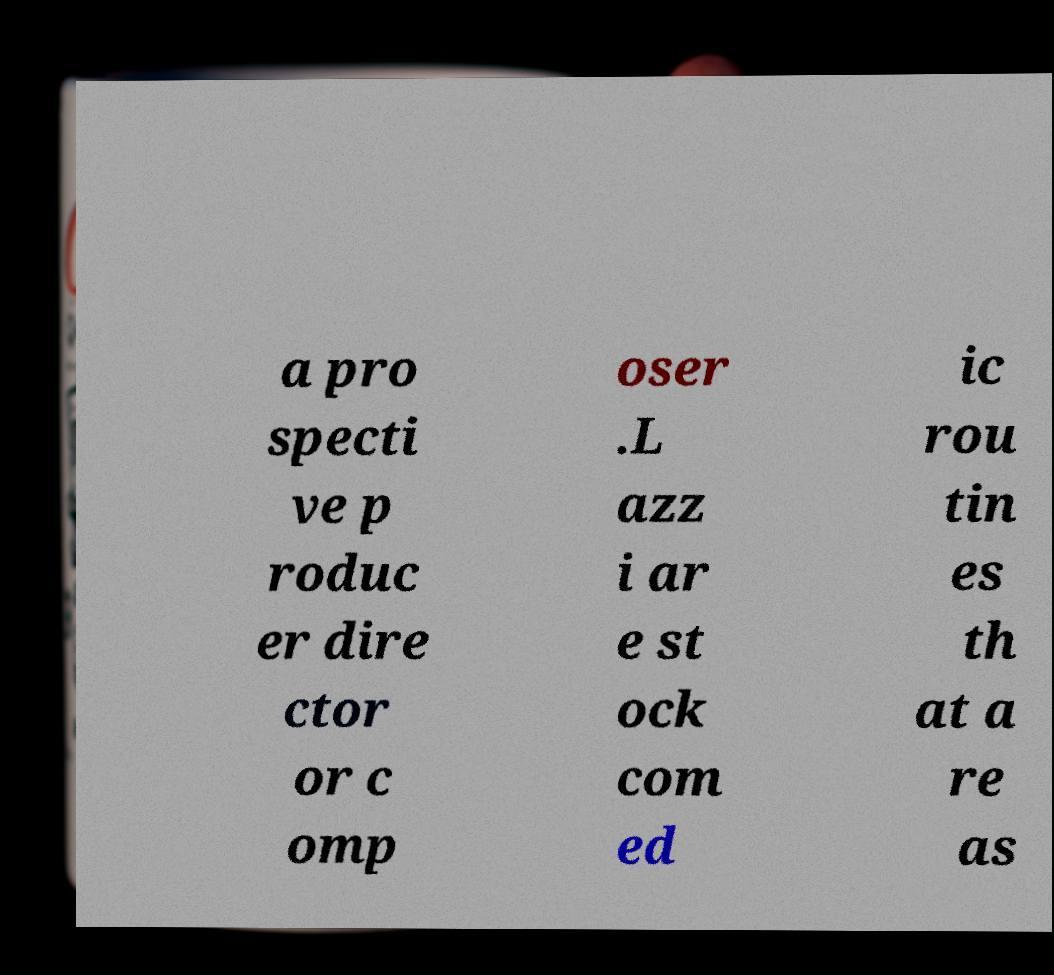What messages or text are displayed in this image? I need them in a readable, typed format. a pro specti ve p roduc er dire ctor or c omp oser .L azz i ar e st ock com ed ic rou tin es th at a re as 